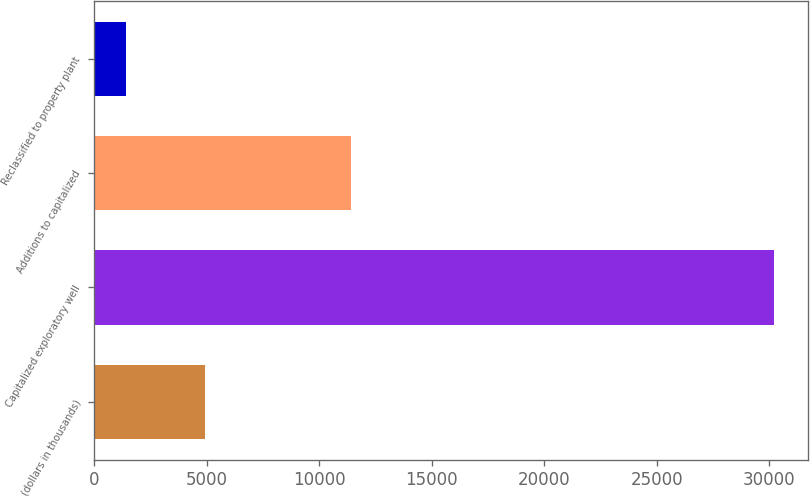Convert chart to OTSL. <chart><loc_0><loc_0><loc_500><loc_500><bar_chart><fcel>(dollars in thousands)<fcel>Capitalized exploratory well<fcel>Additions to capitalized<fcel>Reclassified to property plant<nl><fcel>4928.3<fcel>30237<fcel>11409<fcel>1438<nl></chart> 